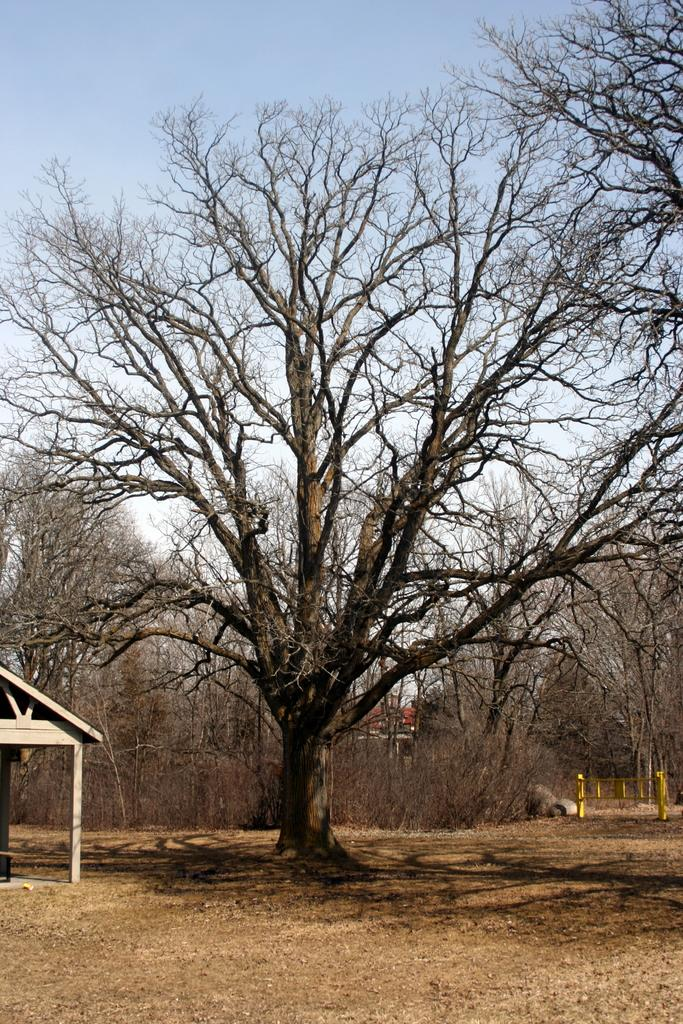What type of vegetation can be seen in the image? There are trees in the image. What part of the natural environment is visible in the image? The ground is visible in the image. What type of structure can be seen in the image? There is a shed in the image. What architectural feature is present in the image? There is a fence in the image. What is visible in the background of the image? The sky is visible in the background of the image. What type of verse can be seen written on the fence in the image? There is no verse written on the fence in the image; it is a simple fence without any text or decoration. What kind of apparatus is used to maintain the trees in the image? There is no apparatus visible in the image for maintaining the trees; the image only shows the trees, shed, fence, and sky. 